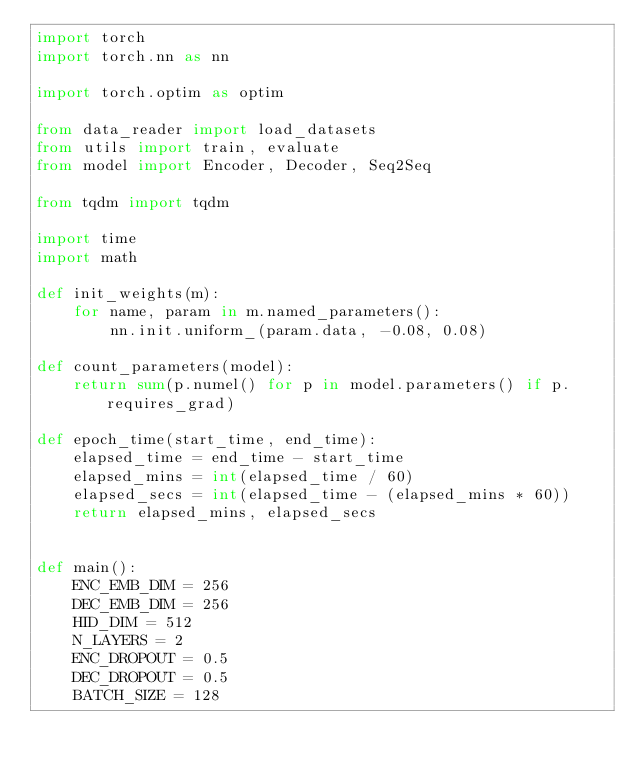Convert code to text. <code><loc_0><loc_0><loc_500><loc_500><_Python_>import torch
import torch.nn as nn

import torch.optim as optim

from data_reader import load_datasets
from utils import train, evaluate
from model import Encoder, Decoder, Seq2Seq

from tqdm import tqdm

import time
import math

def init_weights(m):
    for name, param in m.named_parameters():
        nn.init.uniform_(param.data, -0.08, 0.08)

def count_parameters(model):
    return sum(p.numel() for p in model.parameters() if p.requires_grad)

def epoch_time(start_time, end_time):
    elapsed_time = end_time - start_time
    elapsed_mins = int(elapsed_time / 60)
    elapsed_secs = int(elapsed_time - (elapsed_mins * 60))
    return elapsed_mins, elapsed_secs


def main():
    ENC_EMB_DIM = 256
    DEC_EMB_DIM = 256
    HID_DIM = 512
    N_LAYERS = 2
    ENC_DROPOUT = 0.5
    DEC_DROPOUT = 0.5
    BATCH_SIZE = 128
</code> 